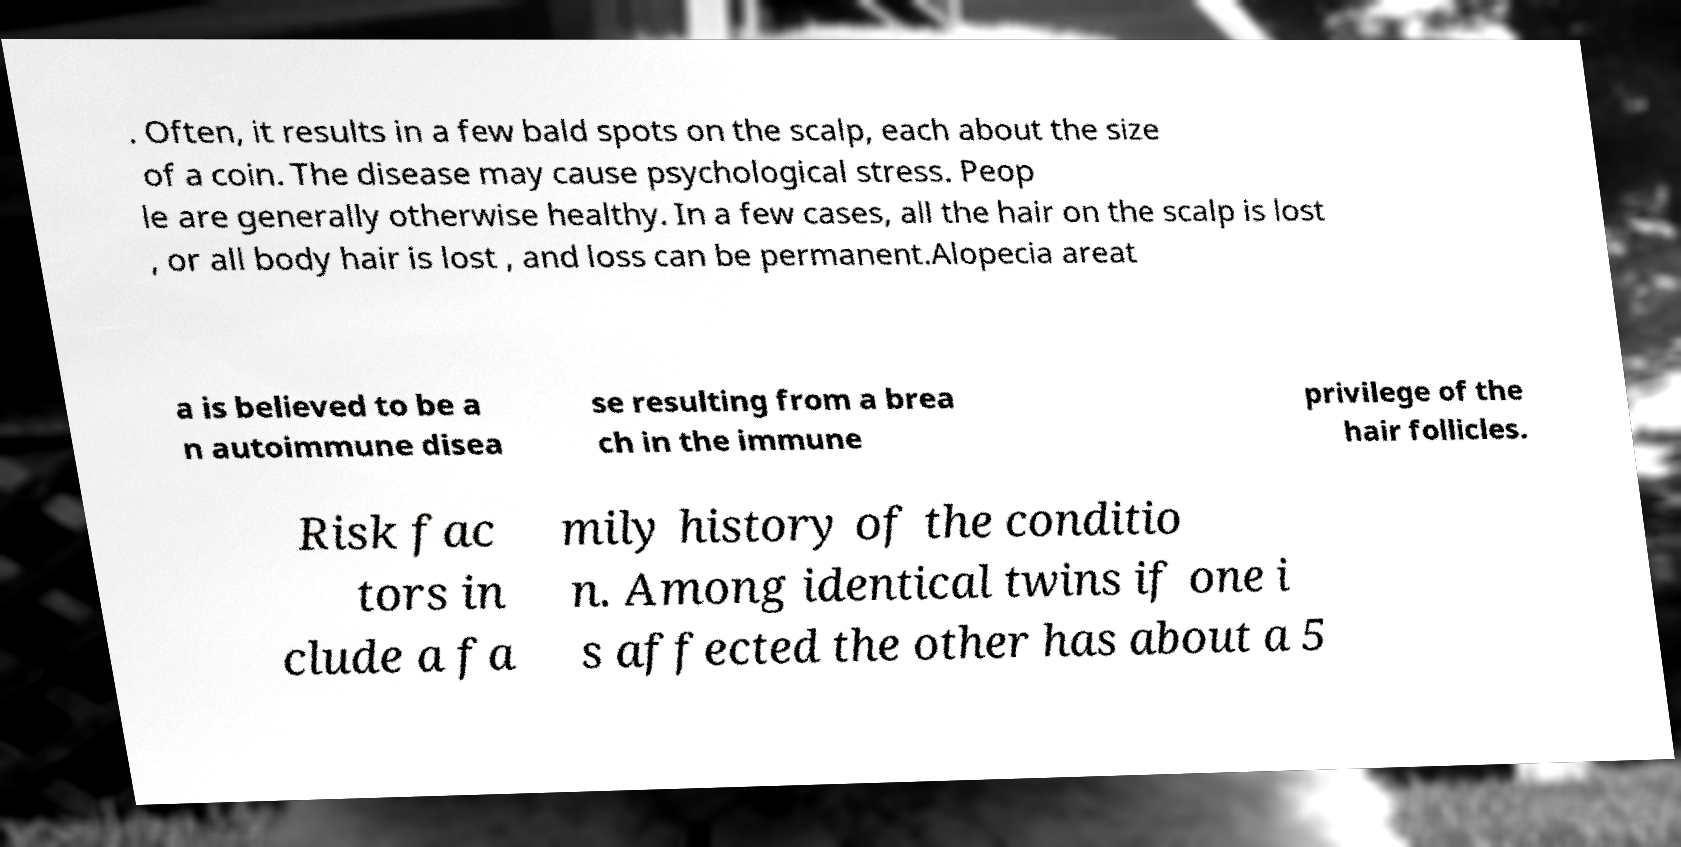I need the written content from this picture converted into text. Can you do that? . Often, it results in a few bald spots on the scalp, each about the size of a coin. The disease may cause psychological stress. Peop le are generally otherwise healthy. In a few cases, all the hair on the scalp is lost , or all body hair is lost , and loss can be permanent.Alopecia areat a is believed to be a n autoimmune disea se resulting from a brea ch in the immune privilege of the hair follicles. Risk fac tors in clude a fa mily history of the conditio n. Among identical twins if one i s affected the other has about a 5 